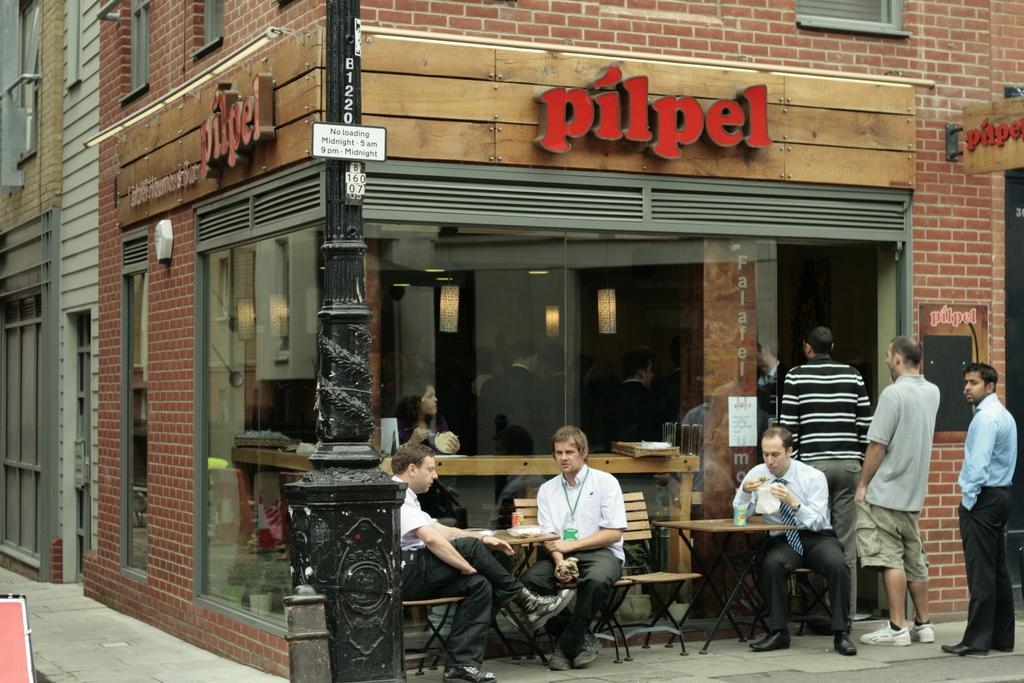What type of establishment is shown in the image? There is a cafe in the image. Are there any people present in the image? Yes, there are people outside the cafe. What are some of the people doing in the image? Some people are sitting around tables outside the cafe. Can you describe any specific features of the cafe's exterior? There is a pole in front of the cafe. What type of pest can be seen attacking the cafe in the image? There is no pest attacking the cafe in the image. What kind of advertisement is displayed on the pole in front of the cafe? The image does not show any advertisement on the pole; it only shows the pole itself. 